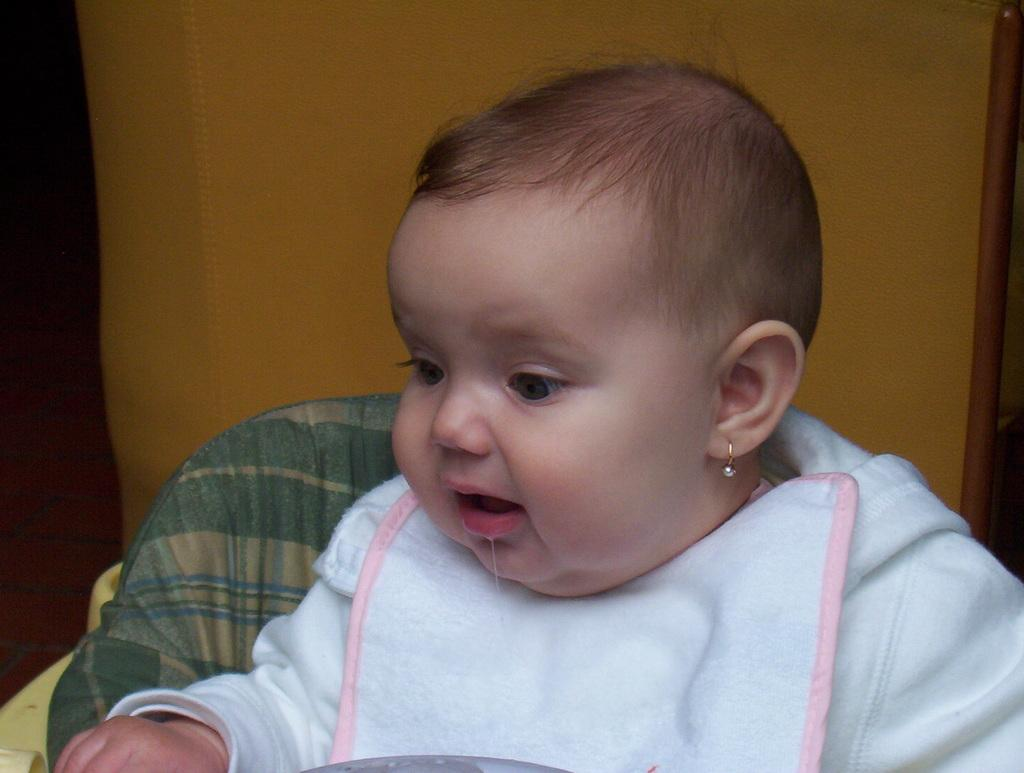What is the main subject of the image? The main subject of the image is a child. What is the child wearing in the image? The child is wearing a white dress in the image. What is the child sitting on in the image? The child is sitting on a baby chair in the image. What type of fork can be seen in the image? There is no fork present in the image. Is the child in the image currently receiving treatment at a hospital? There is no indication in the image that the child is at a hospital or receiving treatment. 